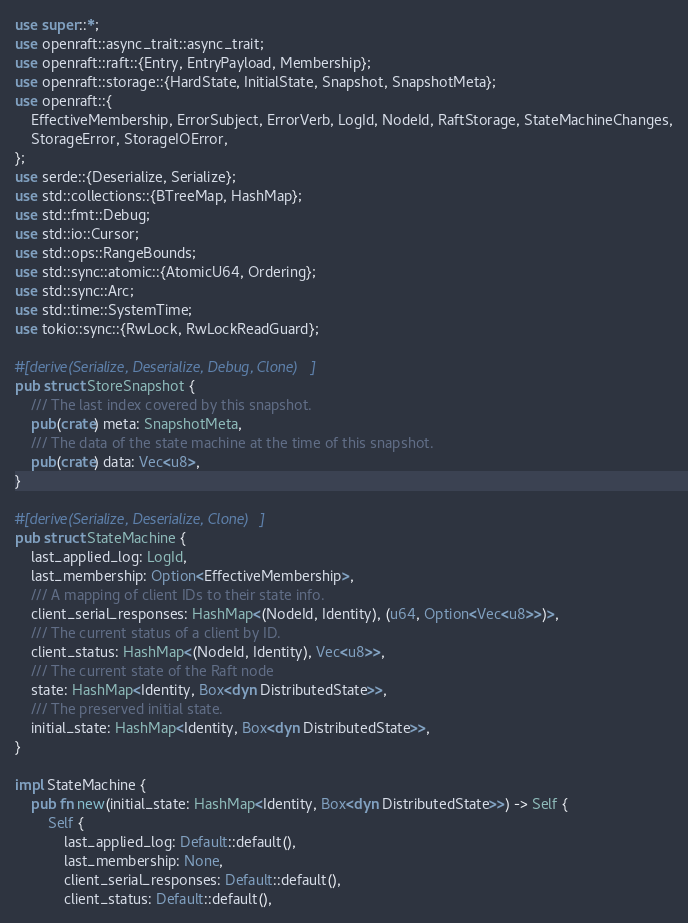<code> <loc_0><loc_0><loc_500><loc_500><_Rust_>use super::*;
use openraft::async_trait::async_trait;
use openraft::raft::{Entry, EntryPayload, Membership};
use openraft::storage::{HardState, InitialState, Snapshot, SnapshotMeta};
use openraft::{
    EffectiveMembership, ErrorSubject, ErrorVerb, LogId, NodeId, RaftStorage, StateMachineChanges,
    StorageError, StorageIOError,
};
use serde::{Deserialize, Serialize};
use std::collections::{BTreeMap, HashMap};
use std::fmt::Debug;
use std::io::Cursor;
use std::ops::RangeBounds;
use std::sync::atomic::{AtomicU64, Ordering};
use std::sync::Arc;
use std::time::SystemTime;
use tokio::sync::{RwLock, RwLockReadGuard};

#[derive(Serialize, Deserialize, Debug, Clone)]
pub struct StoreSnapshot {
    /// The last index covered by this snapshot.
    pub(crate) meta: SnapshotMeta,
    /// The data of the state machine at the time of this snapshot.
    pub(crate) data: Vec<u8>,
}

#[derive(Serialize, Deserialize, Clone)]
pub struct StateMachine {
    last_applied_log: LogId,
    last_membership: Option<EffectiveMembership>,
    /// A mapping of client IDs to their state info.
    client_serial_responses: HashMap<(NodeId, Identity), (u64, Option<Vec<u8>>)>,
    /// The current status of a client by ID.
    client_status: HashMap<(NodeId, Identity), Vec<u8>>,
    /// The current state of the Raft node
    state: HashMap<Identity, Box<dyn DistributedState>>,
    /// The preserved initial state.
    initial_state: HashMap<Identity, Box<dyn DistributedState>>,
}

impl StateMachine {
    pub fn new(initial_state: HashMap<Identity, Box<dyn DistributedState>>) -> Self {
        Self {
            last_applied_log: Default::default(),
            last_membership: None,
            client_serial_responses: Default::default(),
            client_status: Default::default(),</code> 